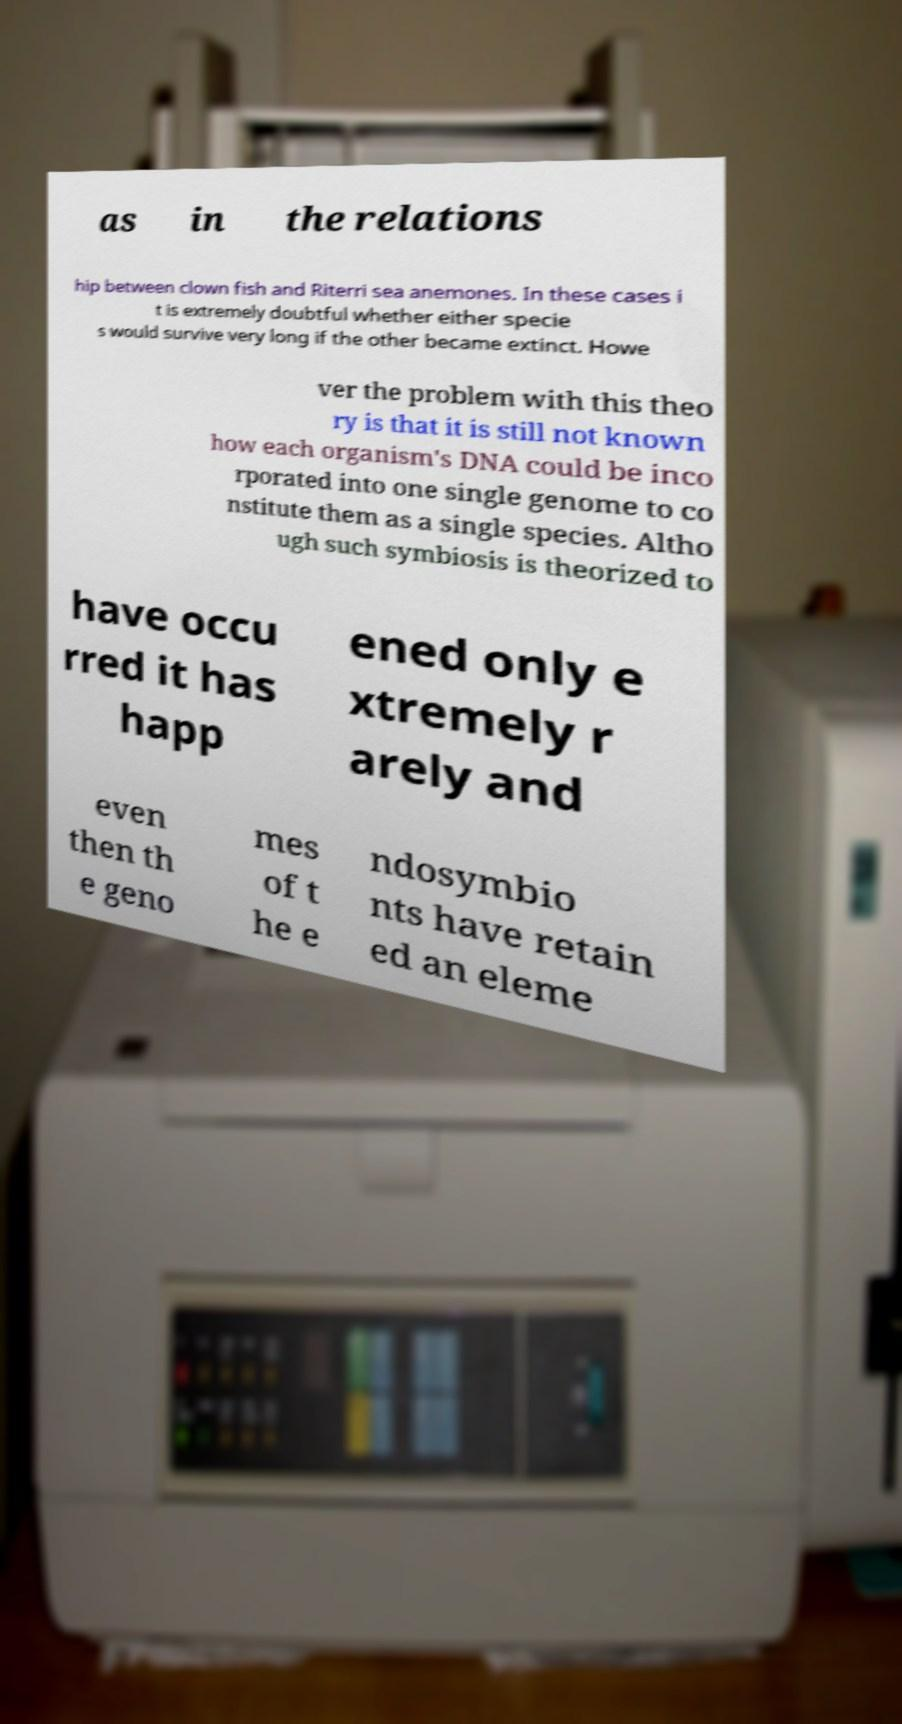Could you assist in decoding the text presented in this image and type it out clearly? as in the relations hip between clown fish and Riterri sea anemones. In these cases i t is extremely doubtful whether either specie s would survive very long if the other became extinct. Howe ver the problem with this theo ry is that it is still not known how each organism's DNA could be inco rporated into one single genome to co nstitute them as a single species. Altho ugh such symbiosis is theorized to have occu rred it has happ ened only e xtremely r arely and even then th e geno mes of t he e ndosymbio nts have retain ed an eleme 